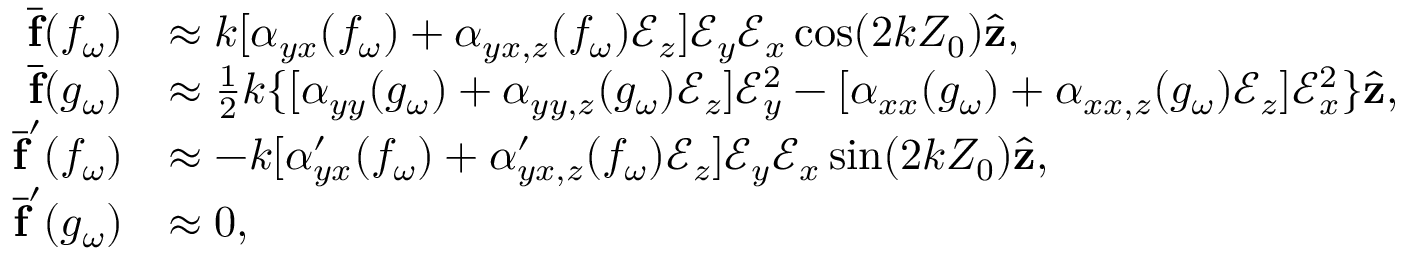Convert formula to latex. <formula><loc_0><loc_0><loc_500><loc_500>\begin{array} { r l } { \overline { f } ( f _ { \omega } ) } & { \approx k [ \alpha _ { y x } ( f _ { \omega } ) + \alpha _ { y x , z } ( f _ { \omega } ) \mathcal { E } _ { z } ] \mathcal { E } _ { y } \mathcal { E } _ { x } \cos ( 2 k Z _ { 0 } ) \hat { z } , } \\ { \overline { f } ( g _ { \omega } ) } & { \approx \frac { 1 } { 2 } k \{ [ \alpha _ { y y } ( g _ { \omega } ) + \alpha _ { y y , z } ( g _ { \omega } ) \mathcal { E } _ { z } ] \mathcal { E } _ { y } ^ { 2 } - [ \alpha _ { x x } ( g _ { \omega } ) + \alpha _ { x x , z } ( g _ { \omega } ) \mathcal { E } _ { z } ] \mathcal { E } _ { x } ^ { 2 } \} \hat { z } , } \\ { \overline { f } ^ { \prime } ( f _ { \omega } ) } & { \approx - k [ \alpha _ { y x } ^ { \prime } ( f _ { \omega } ) + \alpha _ { y x , z } ^ { \prime } ( f _ { \omega } ) \mathcal { E } _ { z } ] \mathcal { E } _ { y } \mathcal { E } _ { x } \sin ( 2 k Z _ { 0 } ) \hat { z } , } \\ { \overline { f } ^ { \prime } ( g _ { \omega } ) } & { \approx 0 , } \end{array}</formula> 